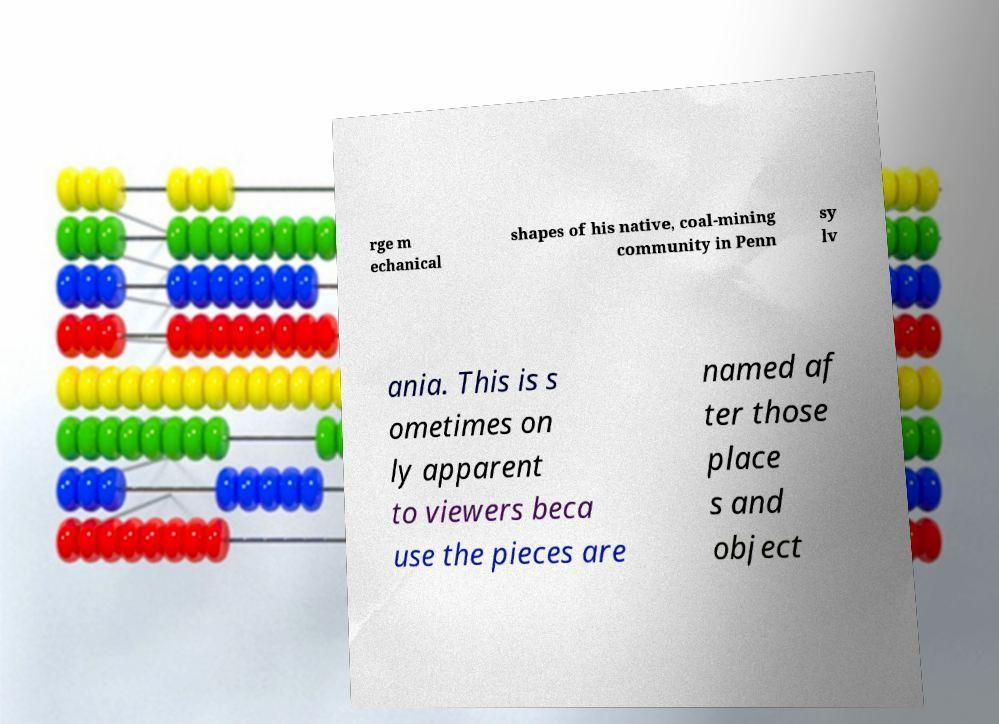Can you read and provide the text displayed in the image?This photo seems to have some interesting text. Can you extract and type it out for me? rge m echanical shapes of his native, coal-mining community in Penn sy lv ania. This is s ometimes on ly apparent to viewers beca use the pieces are named af ter those place s and object 